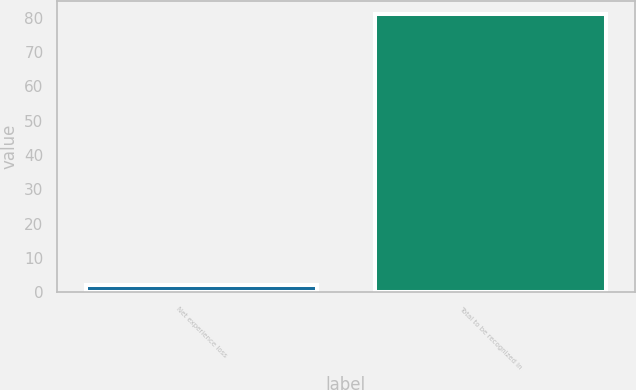Convert chart to OTSL. <chart><loc_0><loc_0><loc_500><loc_500><bar_chart><fcel>Net experience loss<fcel>Total to be recognized in<nl><fcel>2<fcel>81<nl></chart> 